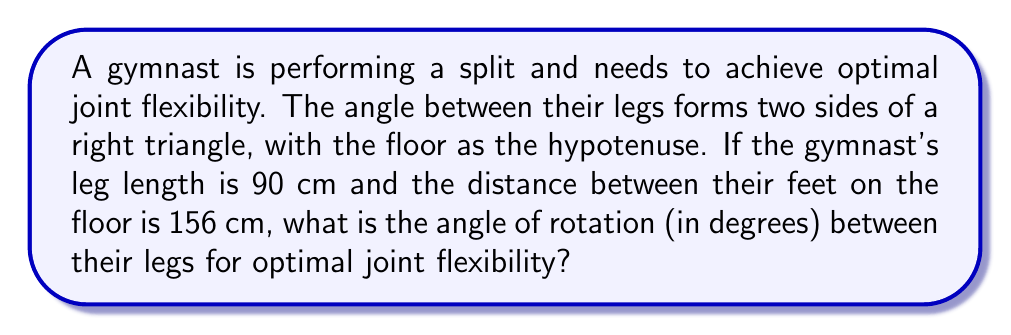Show me your answer to this math problem. Let's approach this step-by-step:

1) We can visualize this as a right triangle where:
   - The legs of the gymnast form two sides of the triangle
   - The floor forms the hypotenuse
   - The angle we're looking for is at the vertex where the legs meet

2) We know:
   - Leg length (side of the triangle) = 90 cm
   - Distance between feet (hypotenuse) = 156 cm

3) We can use the cosine function to find the angle. In a right triangle:

   $$\cos \theta = \frac{\text{adjacent}}{\text{hypotenuse}}$$

4) In our case, half of the angle we're looking for is the angle between one leg and the floor. Let's call this angle $\theta$. Then:

   $$\cos \theta = \frac{78}{90}$$

   (Note: 78 is half of 156, as we're working with half the triangle)

5) To find $\theta$, we take the inverse cosine (arccos):

   $$\theta = \arccos(\frac{78}{90})$$

6) Calculate this:
   
   $$\theta \approx 0.5669 \text{ radians}$$

7) Convert to degrees:

   $$0.5669 \times \frac{180}{\pi} \approx 32.48°$$

8) Remember, this is only half the angle. The full angle of rotation between the legs is twice this:

   $$32.48° \times 2 \approx 64.96°$$

Therefore, the angle of rotation between the gymnast's legs for optimal joint flexibility is approximately 64.96°.
Answer: $64.96°$ 